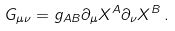<formula> <loc_0><loc_0><loc_500><loc_500>G _ { \mu \nu } = g _ { A B } \partial _ { \mu } X ^ { A } \partial _ { \nu } X ^ { B } \, .</formula> 